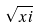<formula> <loc_0><loc_0><loc_500><loc_500>\sqrt { x i }</formula> 